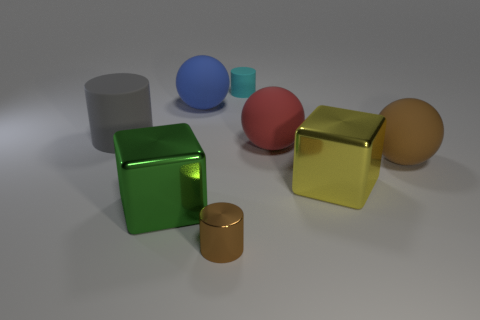Subtract all green balls. Subtract all gray cubes. How many balls are left? 3 Add 1 purple shiny cylinders. How many objects exist? 9 Subtract all cylinders. How many objects are left? 5 Add 1 big gray matte cylinders. How many big gray matte cylinders exist? 2 Subtract 1 brown spheres. How many objects are left? 7 Subtract all yellow things. Subtract all blocks. How many objects are left? 5 Add 5 big red rubber objects. How many big red rubber objects are left? 6 